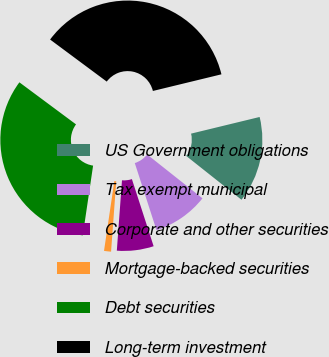Convert chart to OTSL. <chart><loc_0><loc_0><loc_500><loc_500><pie_chart><fcel>US Government obligations<fcel>Tax exempt municipal<fcel>Corporate and other securities<fcel>Mortgage-backed securities<fcel>Debt securities<fcel>Long-term investment<nl><fcel>14.46%<fcel>9.35%<fcel>6.15%<fcel>1.17%<fcel>32.83%<fcel>36.04%<nl></chart> 